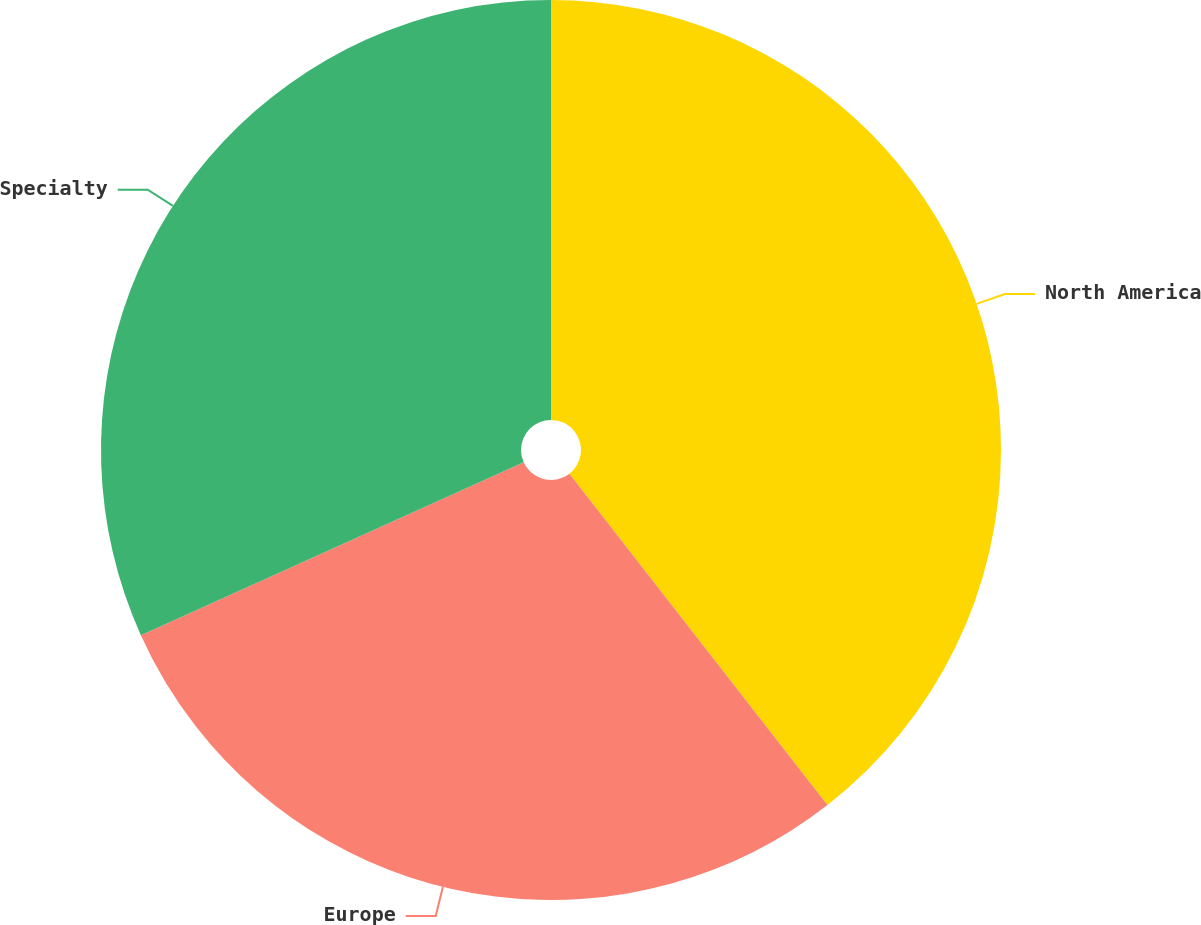Convert chart to OTSL. <chart><loc_0><loc_0><loc_500><loc_500><pie_chart><fcel>North America<fcel>Europe<fcel>Specialty<nl><fcel>39.47%<fcel>28.78%<fcel>31.75%<nl></chart> 